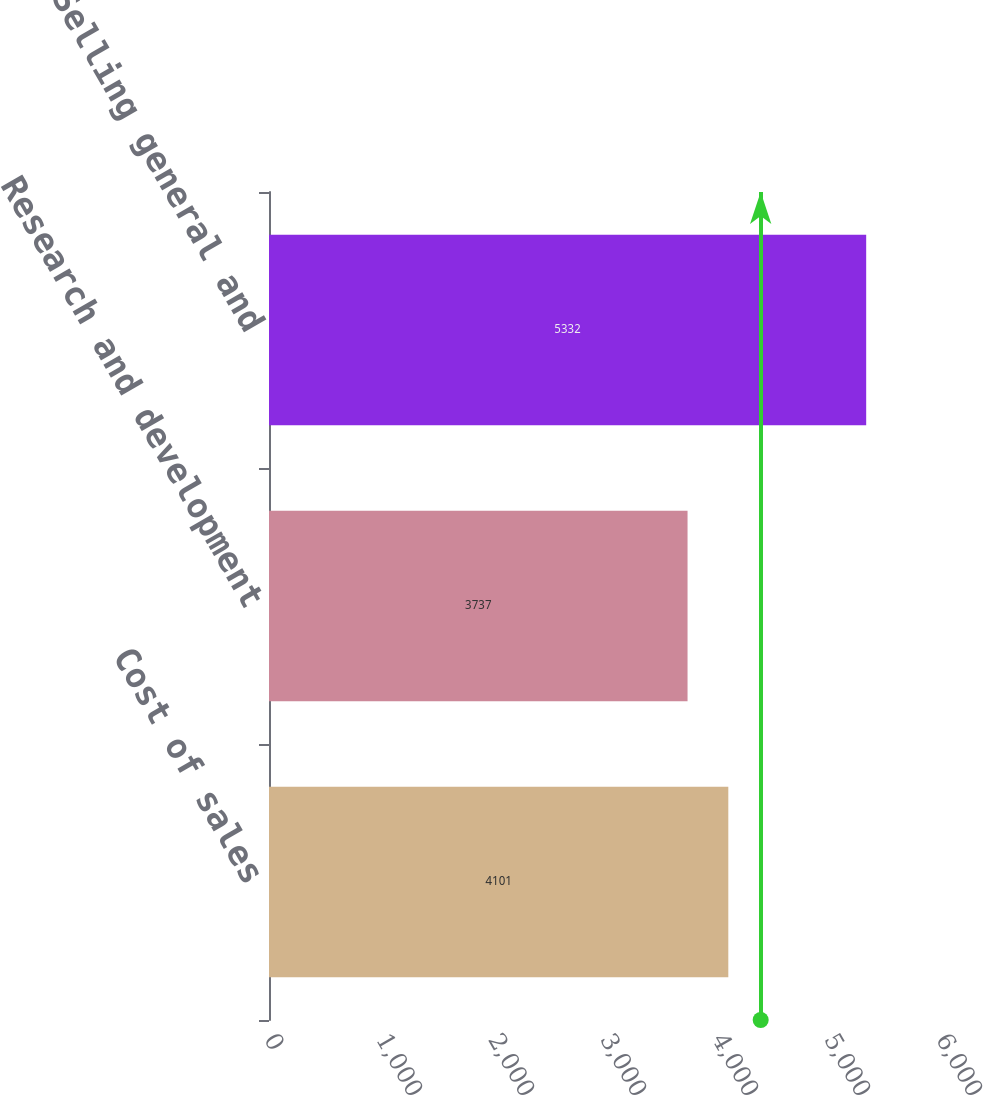<chart> <loc_0><loc_0><loc_500><loc_500><bar_chart><fcel>Cost of sales<fcel>Research and development<fcel>Selling general and<nl><fcel>4101<fcel>3737<fcel>5332<nl></chart> 